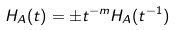<formula> <loc_0><loc_0><loc_500><loc_500>H _ { A } ( t ) = \pm t ^ { - m } H _ { A } ( t ^ { - 1 } )</formula> 